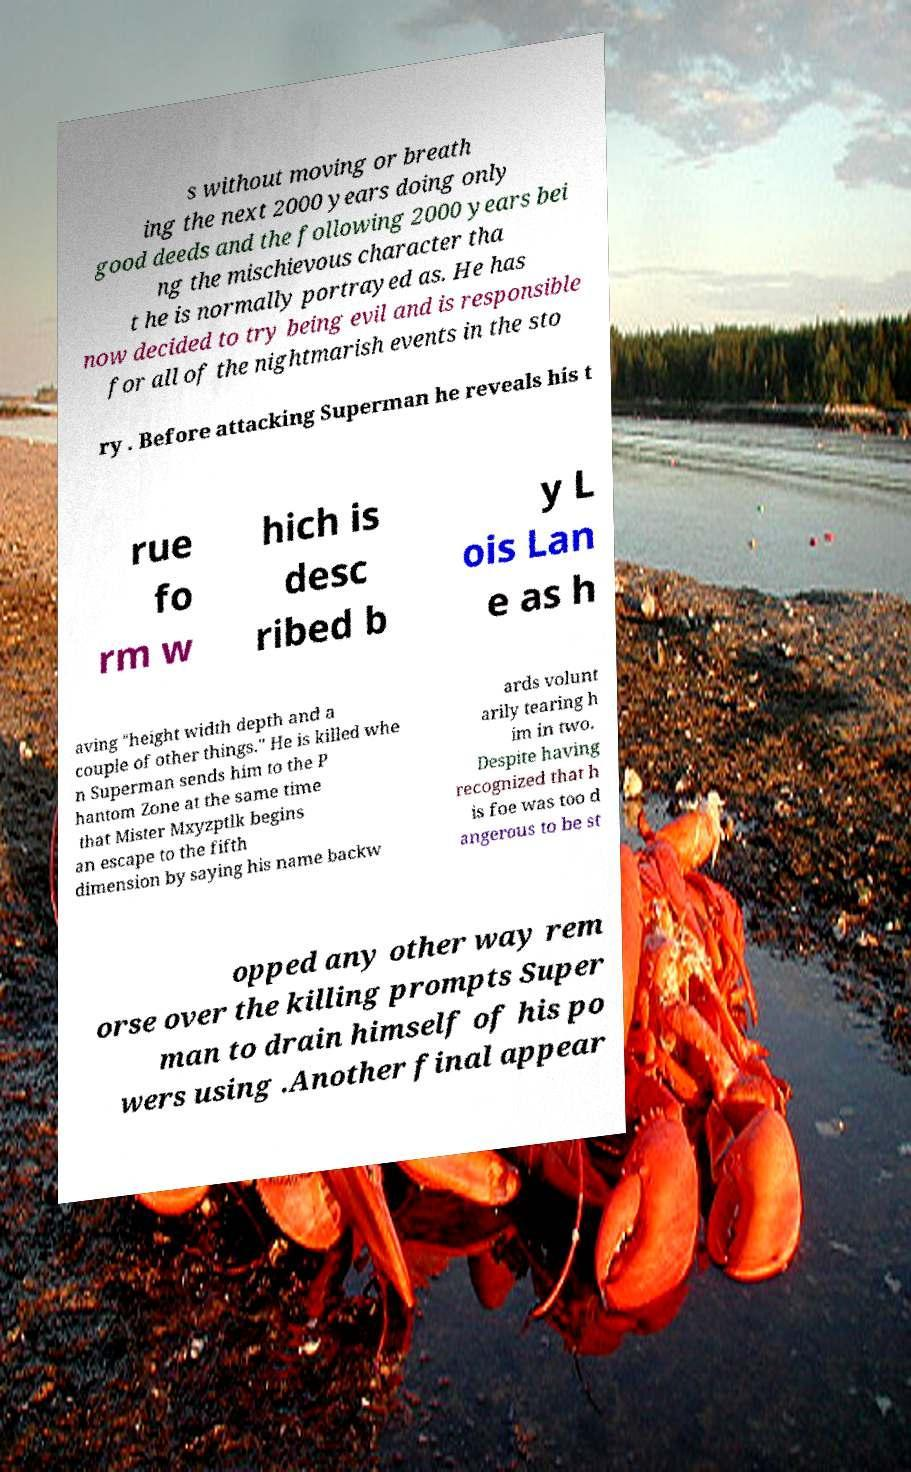Please identify and transcribe the text found in this image. s without moving or breath ing the next 2000 years doing only good deeds and the following 2000 years bei ng the mischievous character tha t he is normally portrayed as. He has now decided to try being evil and is responsible for all of the nightmarish events in the sto ry . Before attacking Superman he reveals his t rue fo rm w hich is desc ribed b y L ois Lan e as h aving "height width depth and a couple of other things." He is killed whe n Superman sends him to the P hantom Zone at the same time that Mister Mxyzptlk begins an escape to the fifth dimension by saying his name backw ards volunt arily tearing h im in two. Despite having recognized that h is foe was too d angerous to be st opped any other way rem orse over the killing prompts Super man to drain himself of his po wers using .Another final appear 